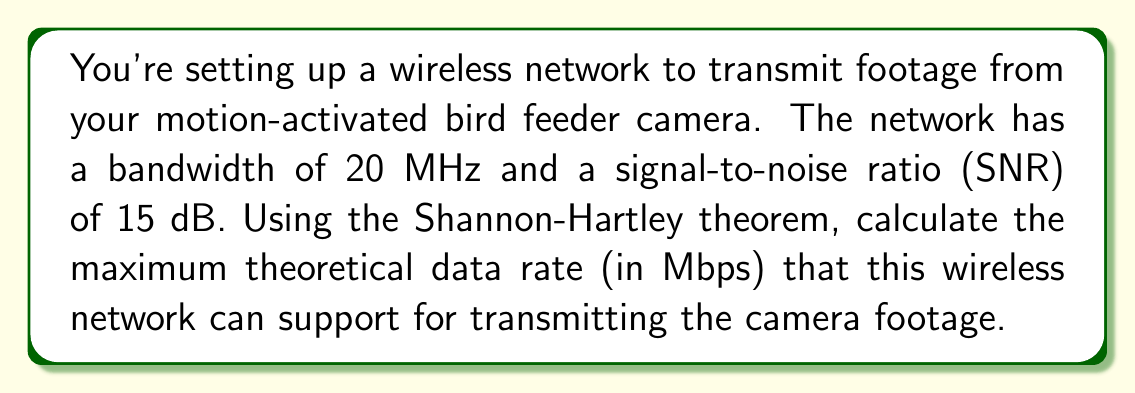Solve this math problem. To solve this problem, we'll use the Shannon-Hartley theorem, which gives the maximum rate at which information can be transmitted over a communications channel of a specified bandwidth in the presence of noise. The theorem is expressed as:

$$C = B \log_2(1 + SNR)$$

Where:
$C$ is the channel capacity in bits per second
$B$ is the bandwidth of the channel in Hertz
$SNR$ is the signal-to-noise ratio

Given:
- Bandwidth $(B) = 20$ MHz $= 20 \times 10^6$ Hz
- SNR $= 15$ dB

Step 1: Convert SNR from dB to linear scale
SNR in dB $= 10 \log_{10}(SNR)$
$15 = 10 \log_{10}(SNR)$
$\frac{15}{10} = \log_{10}(SNR)$
$SNR = 10^{1.5} \approx 31.6228$

Step 2: Apply the Shannon-Hartley theorem
$$\begin{align}
C &= B \log_2(1 + SNR) \\
&= (20 \times 10^6) \log_2(1 + 31.6228) \\
&\approx (20 \times 10^6) \times 5.0224 \\
&\approx 100.448 \times 10^6 \text{ bits per second}
\end{align}$$

Step 3: Convert bits per second to Megabits per second (Mbps)
$100.448 \times 10^6 \text{ bps} = 100.448 \text{ Mbps}$

Therefore, the maximum theoretical data rate that this wireless network can support is approximately 100.448 Mbps.
Answer: 100.448 Mbps 